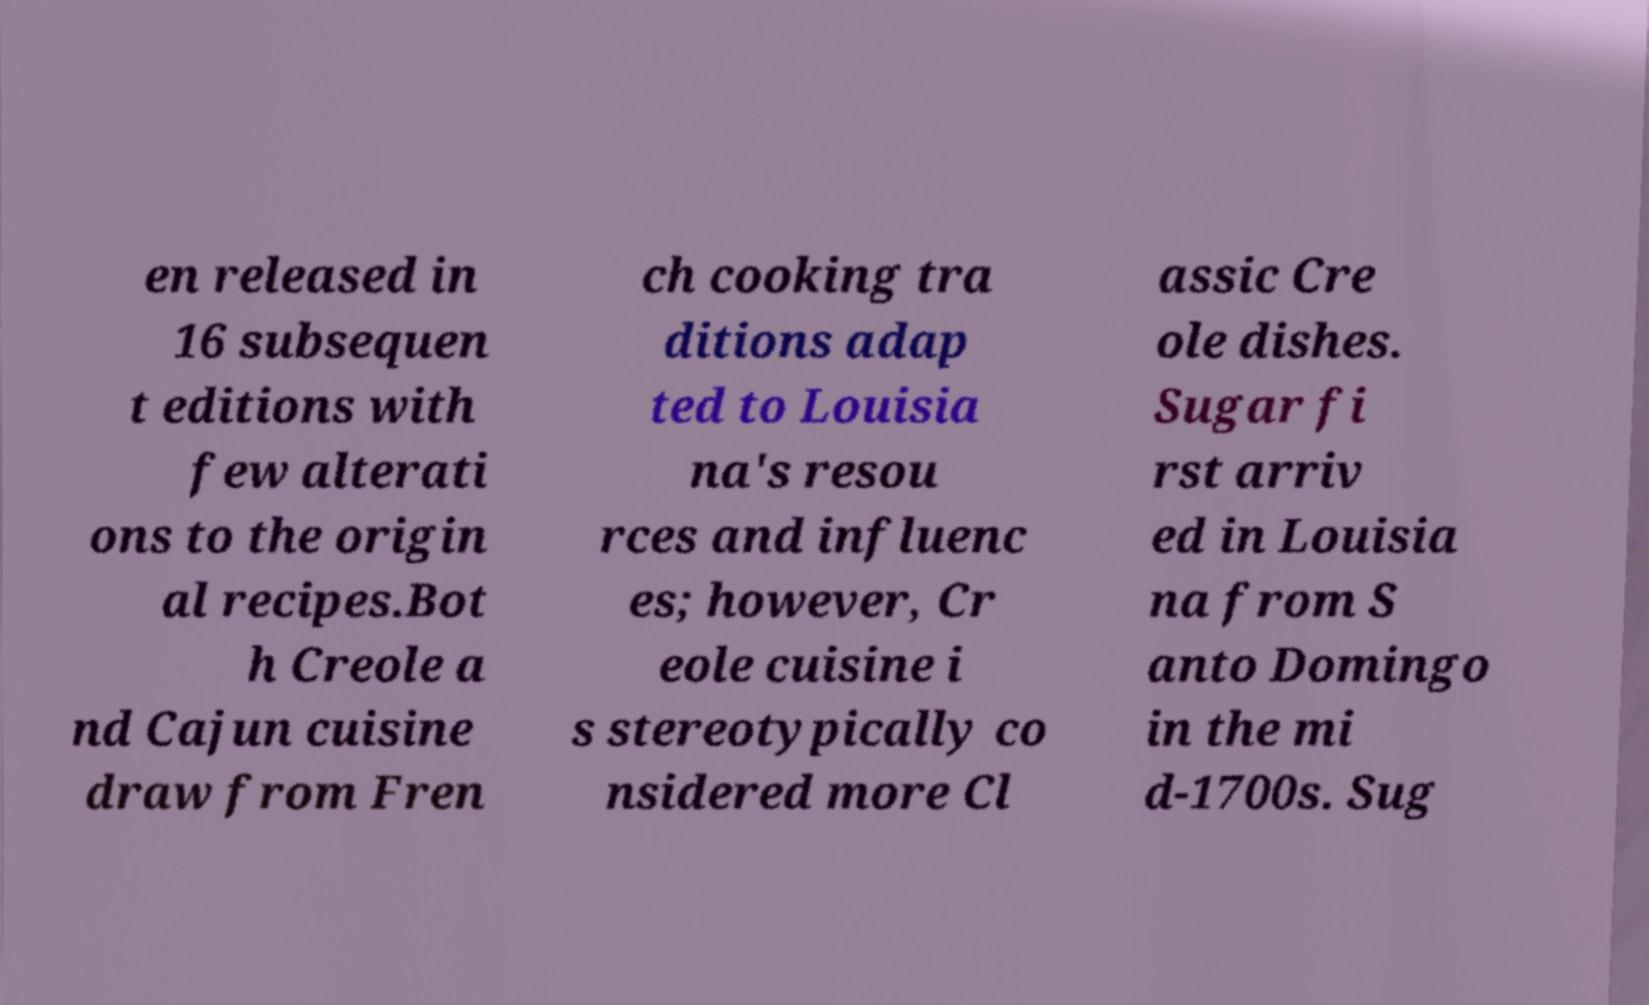Please read and relay the text visible in this image. What does it say? en released in 16 subsequen t editions with few alterati ons to the origin al recipes.Bot h Creole a nd Cajun cuisine draw from Fren ch cooking tra ditions adap ted to Louisia na's resou rces and influenc es; however, Cr eole cuisine i s stereotypically co nsidered more Cl assic Cre ole dishes. Sugar fi rst arriv ed in Louisia na from S anto Domingo in the mi d-1700s. Sug 